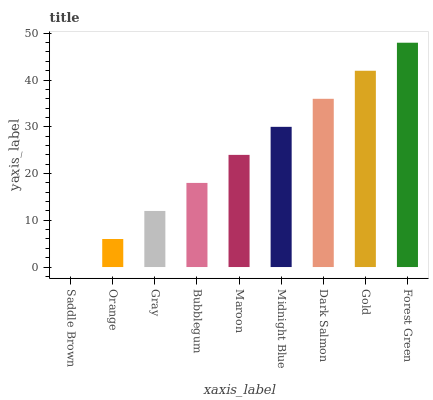Is Saddle Brown the minimum?
Answer yes or no. Yes. Is Forest Green the maximum?
Answer yes or no. Yes. Is Orange the minimum?
Answer yes or no. No. Is Orange the maximum?
Answer yes or no. No. Is Orange greater than Saddle Brown?
Answer yes or no. Yes. Is Saddle Brown less than Orange?
Answer yes or no. Yes. Is Saddle Brown greater than Orange?
Answer yes or no. No. Is Orange less than Saddle Brown?
Answer yes or no. No. Is Maroon the high median?
Answer yes or no. Yes. Is Maroon the low median?
Answer yes or no. Yes. Is Saddle Brown the high median?
Answer yes or no. No. Is Dark Salmon the low median?
Answer yes or no. No. 